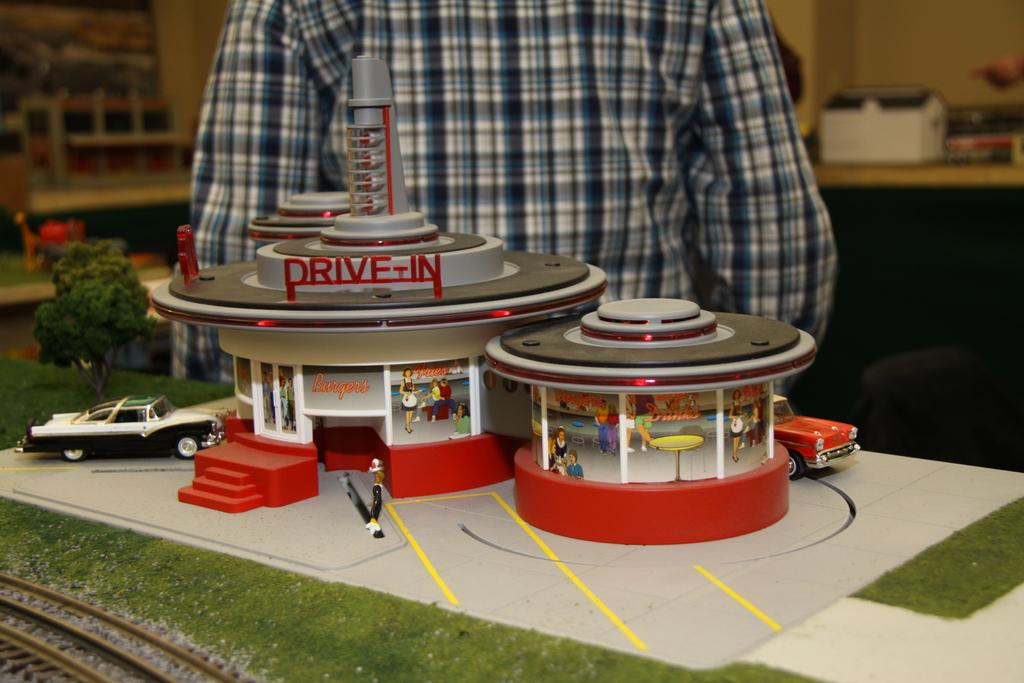<image>
Present a compact description of the photo's key features. Small lego playset with a old style burger drive in 